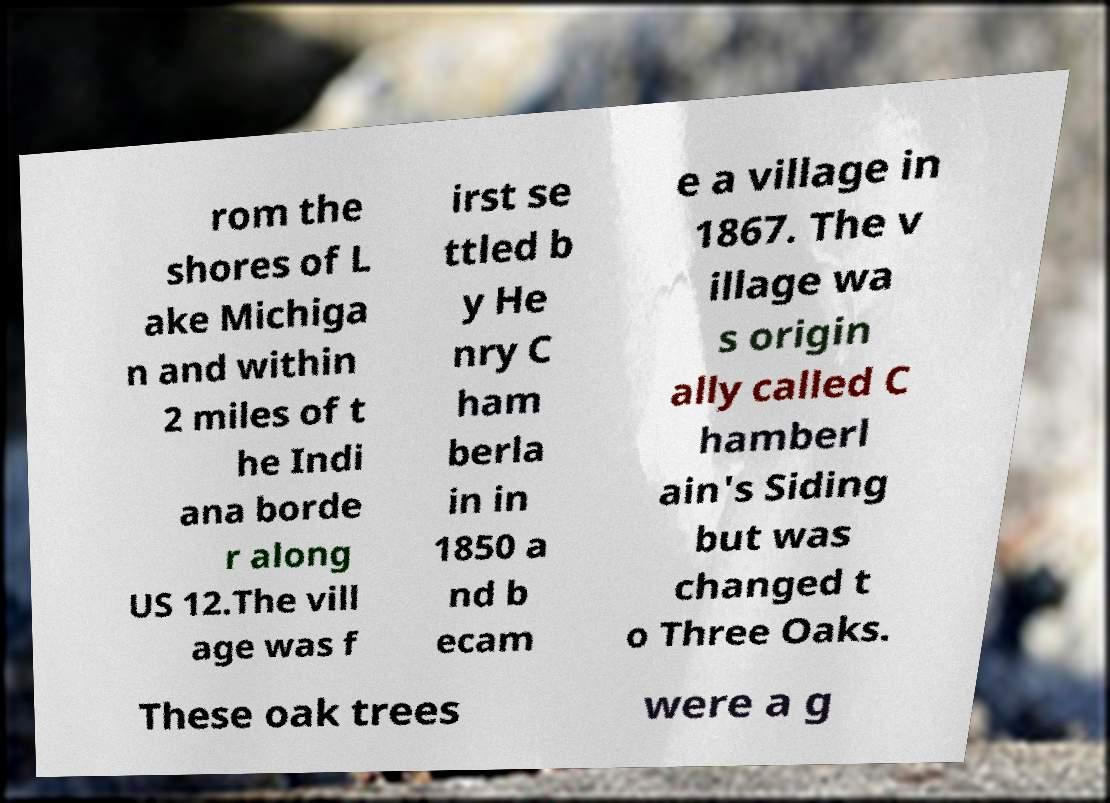There's text embedded in this image that I need extracted. Can you transcribe it verbatim? rom the shores of L ake Michiga n and within 2 miles of t he Indi ana borde r along US 12.The vill age was f irst se ttled b y He nry C ham berla in in 1850 a nd b ecam e a village in 1867. The v illage wa s origin ally called C hamberl ain's Siding but was changed t o Three Oaks. These oak trees were a g 